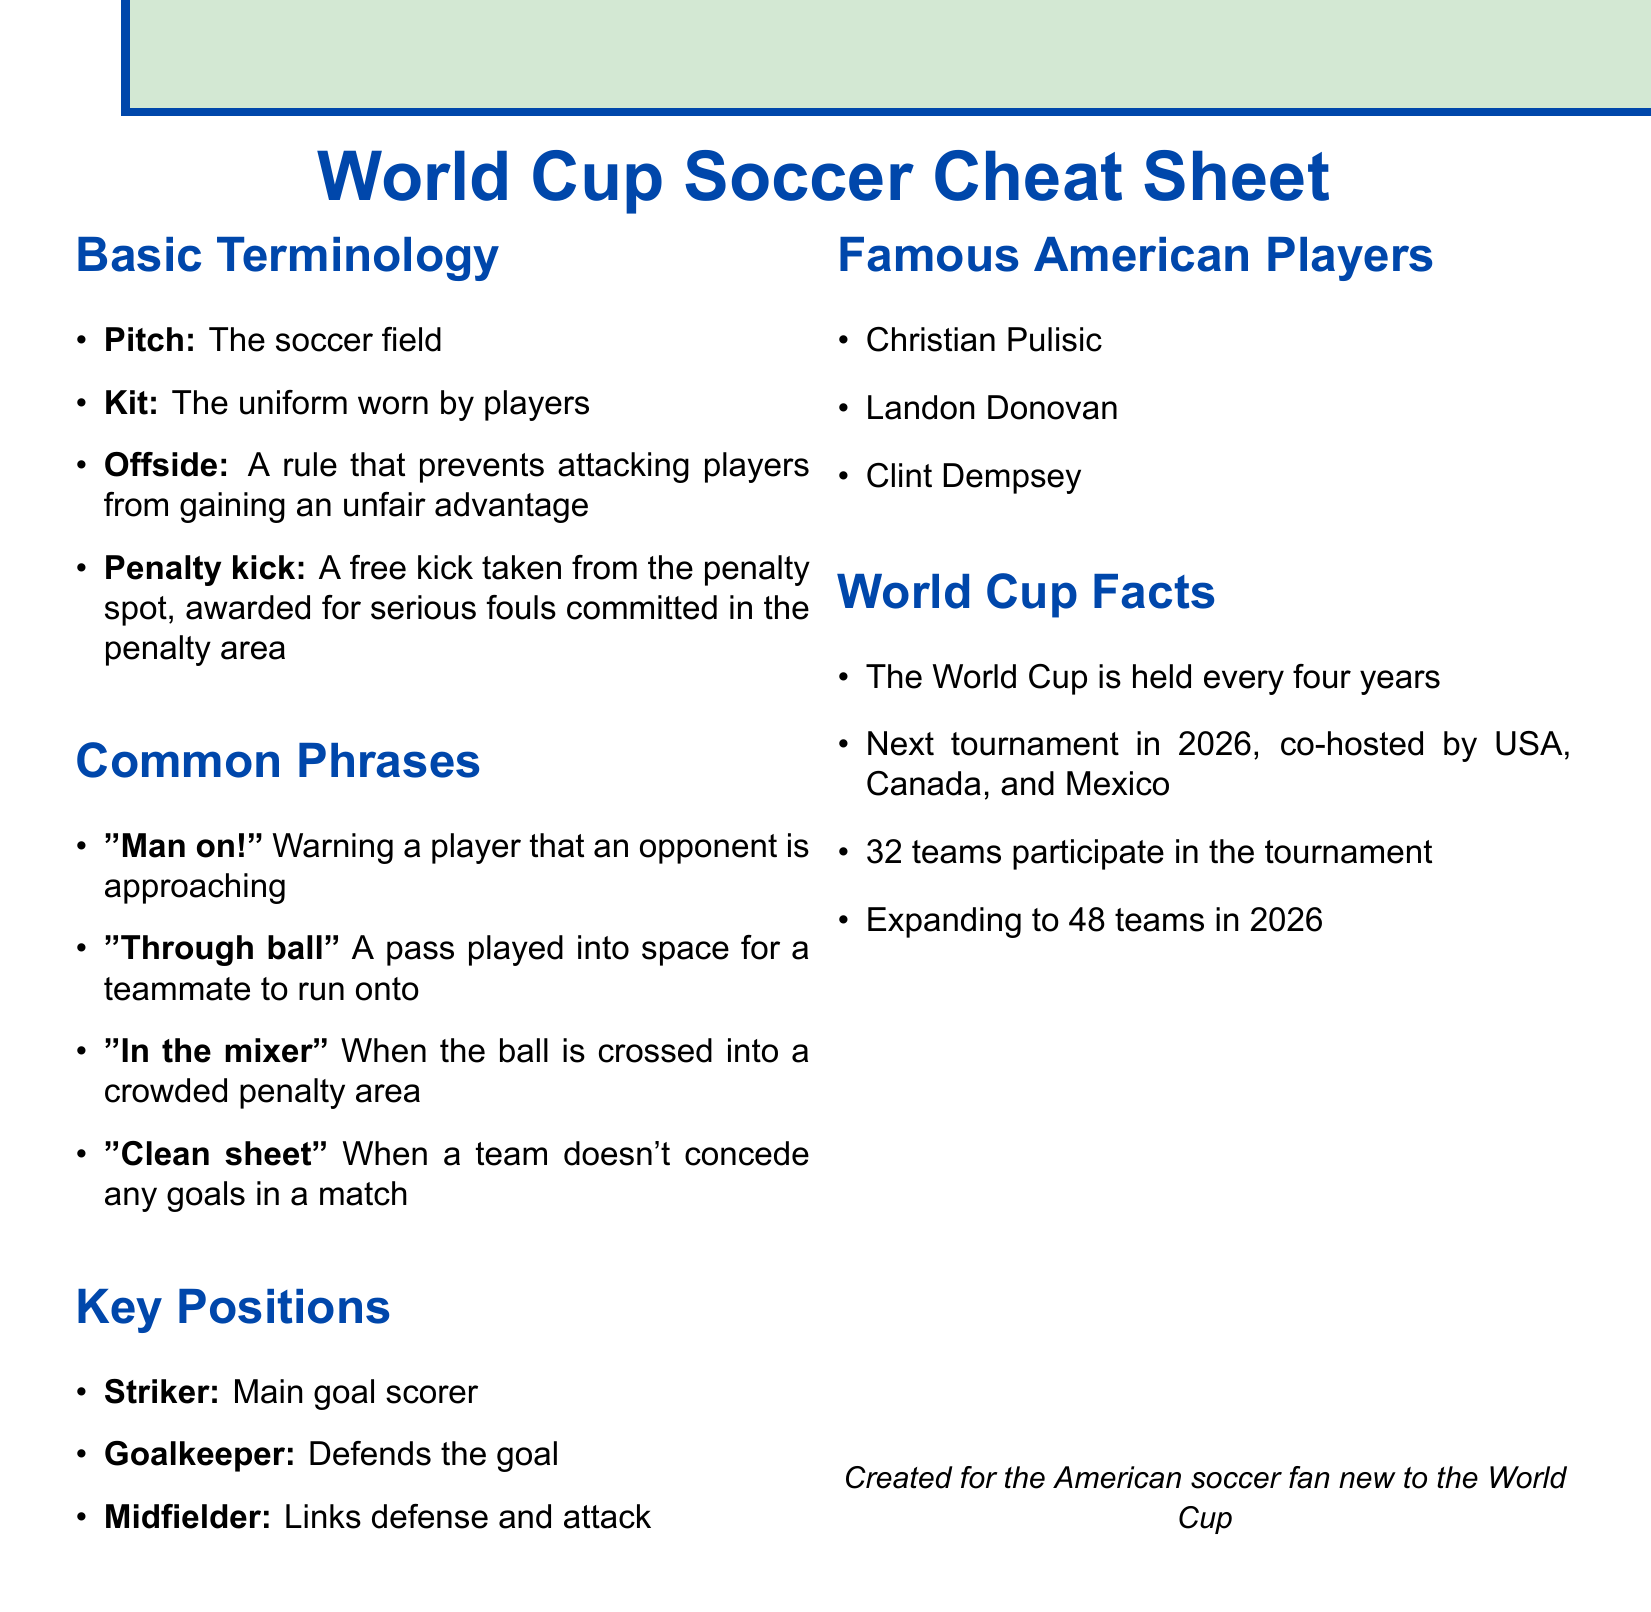What is the soccer field called? The term used for the soccer field in the document is "Pitch".
Answer: Pitch What is a "clean sheet"? A "clean sheet" refers to when a team doesn't concede any goals in a match.
Answer: Doesn't concede any goals Who is the main goal scorer? The document specifies that the "Striker" is the position that serves as the main goal scorer.
Answer: Striker How many teams currently participate in the World Cup? The document states that "32 teams" participate in the tournament currently.
Answer: 32 What year will the next World Cup be held? According to the document, the next World Cup tournament will occur in "2026".
Answer: 2026 What does "Man on!" mean? The phrase "Man on!" serves as a warning to a player that an opponent is approaching.
Answer: Warning a player Who are two famous American soccer players mentioned? The document lists several players, two of them are "Christian Pulisic" and "Landon Donovan".
Answer: Christian Pulisic, Landon Donovan What rule prevents unfair advantage to attacking players? The document refers to the "Offside" rule that prevents attacking players from gaining an unfair advantage.
Answer: Offside In what three countries will the 2026 World Cup be co-hosted? The document mentions that the 2026 World Cup will be co-hosted by "USA, Canada, and Mexico".
Answer: USA, Canada, and Mexico 